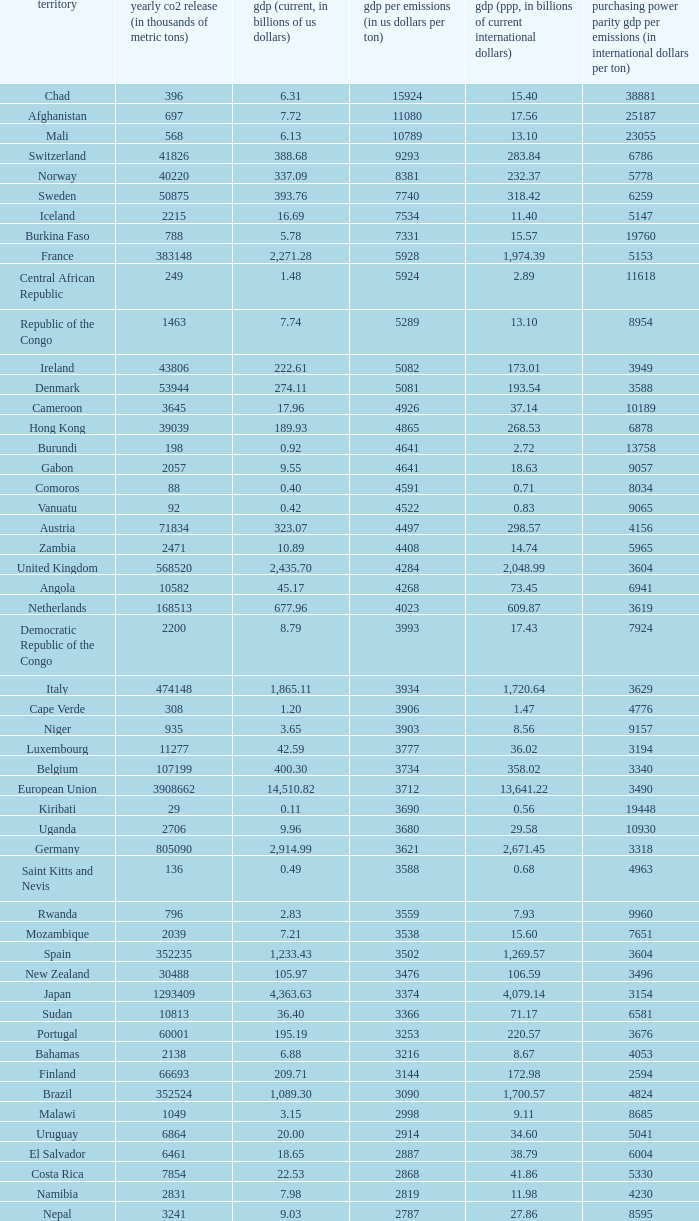Can you parse all the data within this table? {'header': ['territory', 'yearly co2 release (in thousands of metric tons)', 'gdp (current, in billions of us dollars)', 'gdp per emissions (in us dollars per ton)', 'gdp (ppp, in billions of current international dollars)', 'purchasing power parity gdp per emissions (in international dollars per ton)'], 'rows': [['Chad', '396', '6.31', '15924', '15.40', '38881'], ['Afghanistan', '697', '7.72', '11080', '17.56', '25187'], ['Mali', '568', '6.13', '10789', '13.10', '23055'], ['Switzerland', '41826', '388.68', '9293', '283.84', '6786'], ['Norway', '40220', '337.09', '8381', '232.37', '5778'], ['Sweden', '50875', '393.76', '7740', '318.42', '6259'], ['Iceland', '2215', '16.69', '7534', '11.40', '5147'], ['Burkina Faso', '788', '5.78', '7331', '15.57', '19760'], ['France', '383148', '2,271.28', '5928', '1,974.39', '5153'], ['Central African Republic', '249', '1.48', '5924', '2.89', '11618'], ['Republic of the Congo', '1463', '7.74', '5289', '13.10', '8954'], ['Ireland', '43806', '222.61', '5082', '173.01', '3949'], ['Denmark', '53944', '274.11', '5081', '193.54', '3588'], ['Cameroon', '3645', '17.96', '4926', '37.14', '10189'], ['Hong Kong', '39039', '189.93', '4865', '268.53', '6878'], ['Burundi', '198', '0.92', '4641', '2.72', '13758'], ['Gabon', '2057', '9.55', '4641', '18.63', '9057'], ['Comoros', '88', '0.40', '4591', '0.71', '8034'], ['Vanuatu', '92', '0.42', '4522', '0.83', '9065'], ['Austria', '71834', '323.07', '4497', '298.57', '4156'], ['Zambia', '2471', '10.89', '4408', '14.74', '5965'], ['United Kingdom', '568520', '2,435.70', '4284', '2,048.99', '3604'], ['Angola', '10582', '45.17', '4268', '73.45', '6941'], ['Netherlands', '168513', '677.96', '4023', '609.87', '3619'], ['Democratic Republic of the Congo', '2200', '8.79', '3993', '17.43', '7924'], ['Italy', '474148', '1,865.11', '3934', '1,720.64', '3629'], ['Cape Verde', '308', '1.20', '3906', '1.47', '4776'], ['Niger', '935', '3.65', '3903', '8.56', '9157'], ['Luxembourg', '11277', '42.59', '3777', '36.02', '3194'], ['Belgium', '107199', '400.30', '3734', '358.02', '3340'], ['European Union', '3908662', '14,510.82', '3712', '13,641.22', '3490'], ['Kiribati', '29', '0.11', '3690', '0.56', '19448'], ['Uganda', '2706', '9.96', '3680', '29.58', '10930'], ['Germany', '805090', '2,914.99', '3621', '2,671.45', '3318'], ['Saint Kitts and Nevis', '136', '0.49', '3588', '0.68', '4963'], ['Rwanda', '796', '2.83', '3559', '7.93', '9960'], ['Mozambique', '2039', '7.21', '3538', '15.60', '7651'], ['Spain', '352235', '1,233.43', '3502', '1,269.57', '3604'], ['New Zealand', '30488', '105.97', '3476', '106.59', '3496'], ['Japan', '1293409', '4,363.63', '3374', '4,079.14', '3154'], ['Sudan', '10813', '36.40', '3366', '71.17', '6581'], ['Portugal', '60001', '195.19', '3253', '220.57', '3676'], ['Bahamas', '2138', '6.88', '3216', '8.67', '4053'], ['Finland', '66693', '209.71', '3144', '172.98', '2594'], ['Brazil', '352524', '1,089.30', '3090', '1,700.57', '4824'], ['Malawi', '1049', '3.15', '2998', '9.11', '8685'], ['Uruguay', '6864', '20.00', '2914', '34.60', '5041'], ['El Salvador', '6461', '18.65', '2887', '38.79', '6004'], ['Costa Rica', '7854', '22.53', '2868', '41.86', '5330'], ['Namibia', '2831', '7.98', '2819', '11.98', '4230'], ['Nepal', '3241', '9.03', '2787', '27.86', '8595'], ['Greece', '96382', '267.71', '2778', '303.60', '3150'], ['Samoa', '158', '0.43', '2747', '0.95', '5987'], ['Dominica', '117', '0.32', '2709', '0.66', '5632'], ['Latvia', '7462', '19.94', '2672', '35.22', '4720'], ['Tanzania', '5372', '14.35', '2671', '44.46', '8276'], ['Haiti', '1811', '4.84', '2670', '10.52', '5809'], ['Panama', '6428', '17.13', '2666', '30.21', '4700'], ['Swaziland', '1016', '2.67', '2629', '5.18', '5095'], ['Guatemala', '11766', '30.26', '2572', '57.77', '4910'], ['Slovenia', '15173', '38.94', '2566', '51.14', '3370'], ['Colombia', '63422', '162.50', '2562', '342.77', '5405'], ['Malta', '2548', '6.44', '2528', '8.88', '3485'], ['Ivory Coast', '6882', '17.38', '2526', '31.22', '4536'], ['Ethiopia', '6006', '15.17', '2525', '54.39', '9055'], ['Saint Lucia', '367', '0.93', '2520', '1.69', '4616'], ['Saint Vincent and the Grenadines', '198', '0.50', '2515', '0.96', '4843'], ['Singapore', '56217', '139.18', '2476', '208.75', '3713'], ['Laos', '1426', '3.51', '2459', '11.41', '8000'], ['Bhutan', '381', '0.93', '2444', '2.61', '6850'], ['Chile', '60100', '146.76', '2442', '214.41', '3568'], ['Peru', '38643', '92.31', '2389', '195.99', '5072'], ['Barbados', '1338', '3.19', '2385', '4.80', '3590'], ['Sri Lanka', '11876', '28.28', '2381', '77.51', '6526'], ['Botswana', '4770', '11.30', '2369', '23.51', '4929'], ['Antigua and Barbuda', '425', '1.01', '2367', '1.41', '3315'], ['Cyprus', '7788', '18.43', '2366', '19.99', '2566'], ['Canada', '544680', '1,278.97', '2348', '1,203.74', '2210'], ['Grenada', '242', '0.56', '2331', '1.05', '4331'], ['Paraguay', '3986', '9.28', '2327', '24.81', '6224'], ['United States', '5752289', '13,178.35', '2291', '13,178.35', '2291'], ['Equatorial Guinea', '4356', '9.60', '2205', '15.76', '3618'], ['Senegal', '4261', '9.37', '2198', '19.30', '4529'], ['Eritrea', '554', '1.21', '2186', '3.48', '6283'], ['Mexico', '436150', '952.34', '2184', '1,408.81', '3230'], ['Guinea', '1360', '2.90', '2135', '9.29', '6829'], ['Lithuania', '14190', '30.08', '2120', '54.04', '3808'], ['Albania', '4301', '9.11', '2119', '18.34', '4264'], ['Croatia', '23683', '49.04', '2071', '72.63', '3067'], ['Israel', '70440', '143.98', '2044', '174.61', '2479'], ['Australia', '372013', '755.21', '2030', '713.96', '1919'], ['South Korea', '475248', '952.03', '2003', '1,190.70', '2505'], ['Fiji', '1610', '3.17', '1967', '3.74', '2320'], ['Turkey', '269452', '529.19', '1964', '824.58', '3060'], ['Hungary', '57644', '113.05', '1961', '183.84', '3189'], ['Madagascar', '2834', '5.52', '1947', '16.84', '5943'], ['Brunei', '5911', '11.47', '1940', '18.93', '3203'], ['Timor-Leste', '176', '0.33', '1858', '1.96', '11153'], ['Solomon Islands', '180', '0.33', '1856', '0.86', '4789'], ['Kenya', '12151', '22.52', '1853', '52.74', '4340'], ['Togo', '1221', '2.22', '1818', '4.96', '4066'], ['Tonga', '132', '0.24', '1788', '0.54', '4076'], ['Cambodia', '4074', '7.26', '1783', '23.03', '5653'], ['Dominican Republic', '20357', '35.28', '1733', '63.94', '3141'], ['Philippines', '68328', '117.57', '1721', '272.25', '3984'], ['Bolivia', '6973', '11.53', '1653', '37.37', '5359'], ['Mauritius', '3850', '6.32', '1641', '13.09', '3399'], ['Mauritania', '1665', '2.70', '1621', '5.74', '3448'], ['Djibouti', '488', '0.77', '1576', '1.61', '3297'], ['Bangladesh', '41609', '65.20', '1567', '190.93', '4589'], ['Benin', '3109', '4.74', '1524', '11.29', '3631'], ['Gambia', '334', '0.51', '1521', '1.92', '5743'], ['Nigeria', '97262', '146.89', '1510', '268.21', '2758'], ['Honduras', '7194', '10.84', '1507', '28.20', '3920'], ['Slovakia', '37459', '56.00', '1495', '96.76', '2583'], ['Belize', '818', '1.21', '1483', '2.31', '2823'], ['Lebanon', '15330', '22.44', '1464', '40.46', '2639'], ['Armenia', '4371', '6.38', '1461', '14.68', '3357'], ['Morocco', '45316', '65.64', '1448', '120.32', '2655'], ['Burma', '10025', '14.50', '1447', '55.55', '5541'], ['Sierra Leone', '994', '1.42', '1433', '3.62', '3644'], ['Georgia', '5518', '7.77', '1408', '17.77', '3221'], ['Ghana', '9240', '12.73', '1378', '28.72', '3108'], ['Tunisia', '23126', '31.11', '1345', '70.57', '3052'], ['Ecuador', '31328', '41.40', '1322', '94.48', '3016'], ['Seychelles', '744', '0.97', '1301', '1.61', '2157'], ['Romania', '98490', '122.70', '1246', '226.51', '2300'], ['Qatar', '46193', '56.92', '1232', '66.90', '1448'], ['Argentina', '173536', '212.71', '1226', '469.75', '2707'], ['Czech Republic', '116991', '142.31', '1216', '228.48', '1953'], ['Nicaragua', '4334', '5.26', '1215', '14.93', '3444'], ['São Tomé and Príncipe', '103', '0.13', '1214', '0.24', '2311'], ['Papua New Guinea', '4620', '5.61', '1213', '10.91', '2361'], ['United Arab Emirates', '139553', '164.17', '1176', '154.35', '1106'], ['Kuwait', '86599', '101.56', '1173', '119.96', '1385'], ['Guinea-Bissau', '279', '0.32', '1136', '0.76', '2724'], ['Indonesia', '333483', '364.35', '1093', '767.92', '2303'], ['Venezuela', '171593', '184.25', '1074', '300.80', '1753'], ['Poland', '318219', '341.67', '1074', '567.94', '1785'], ['Maldives', '869', '0.92', '1053', '1.44', '1654'], ['Libya', '55495', '55.08', '992', '75.47', '1360'], ['Jamaica', '12151', '11.45', '942', '19.93', '1640'], ['Estonia', '17523', '16.45', '939', '25.31', '1444'], ['Saudi Arabia', '381564', '356.63', '935', '522.12', '1368'], ['Yemen', '21201', '19.06', '899', '49.21', '2321'], ['Pakistan', '142659', '127.49', '894', '372.96', '2614'], ['Algeria', '132715', '116.83', '880', '209.40', '1578'], ['Suriname', '2438', '2.14', '878', '3.76', '1543'], ['Oman', '41378', '35.73', '863', '56.44', '1364'], ['Malaysia', '187865', '156.86', '835', '328.97', '1751'], ['Liberia', '785', '0.61', '780', '1.19', '1520'], ['Thailand', '272521', '206.99', '760', '483.56', '1774'], ['Bahrain', '21292', '15.85', '744', '22.41', '1053'], ['Jordan', '20724', '14.84', '716', '26.25', '1266'], ['Bulgaria', '48085', '31.69', '659', '79.24', '1648'], ['Egypt', '166800', '107.38', '644', '367.64', '2204'], ['Russia', '1564669', '989.43', '632', '1,887.61', '1206'], ['South Africa', '414649', '257.89', '622', '433.51', '1045'], ['Serbia and Montenegro', '53266', '32.30', '606', '72.93', '1369'], ['Guyana', '1507', '0.91', '606', '2.70', '1792'], ['Azerbaijan', '35050', '21.03', '600', '51.71', '1475'], ['Macedonia', '10875', '6.38', '587', '16.14', '1484'], ['India', '1510351', '874.77', '579', '2,672.66', '1770'], ['Trinidad and Tobago', '33601', '19.38', '577', '23.62', '703'], ['Vietnam', '106132', '60.93', '574', '198.94', '1874'], ['Belarus', '68849', '36.96', '537', '94.80', '1377'], ['Iraq', '92572', '49.27', '532', '90.51', '978'], ['Kyrgyzstan', '5566', '2.84', '510', '9.45', '1698'], ['Zimbabwe', '11081', '5.60', '505', '2.29', '207'], ['Syria', '68460', '33.51', '489', '82.09', '1199'], ['Turkmenistan', '44103', '21.40', '485', '23.40', '531'], ['Iran', '466976', '222.13', '476', '693.32', '1485'], ['Bosnia and Herzegovina', '27438', '12.28', '447', '25.70', '937'], ['Tajikistan', '6391', '2.81', '440', '10.69', '1672'], ['Moldova', '7821', '3.41', '436', '9.19', '1175'], ['China', '6103493', '2,657.84', '435', '6,122.24', '1003'], ['Kazakhstan', '193508', '81.00', '419', '150.56', '778'], ['Ukraine', '319158', '108.00', '338', '291.30', '913'], ['Mongolia', '9442', '3.16', '334', '7.47', '791']]} When the gdp (current, in billions of us dollars) is 162.50, what is the gdp? 2562.0. 